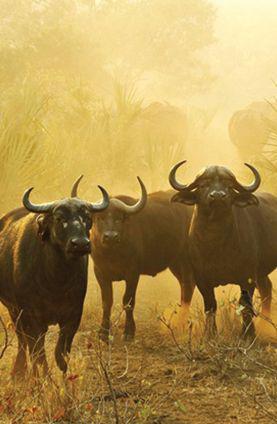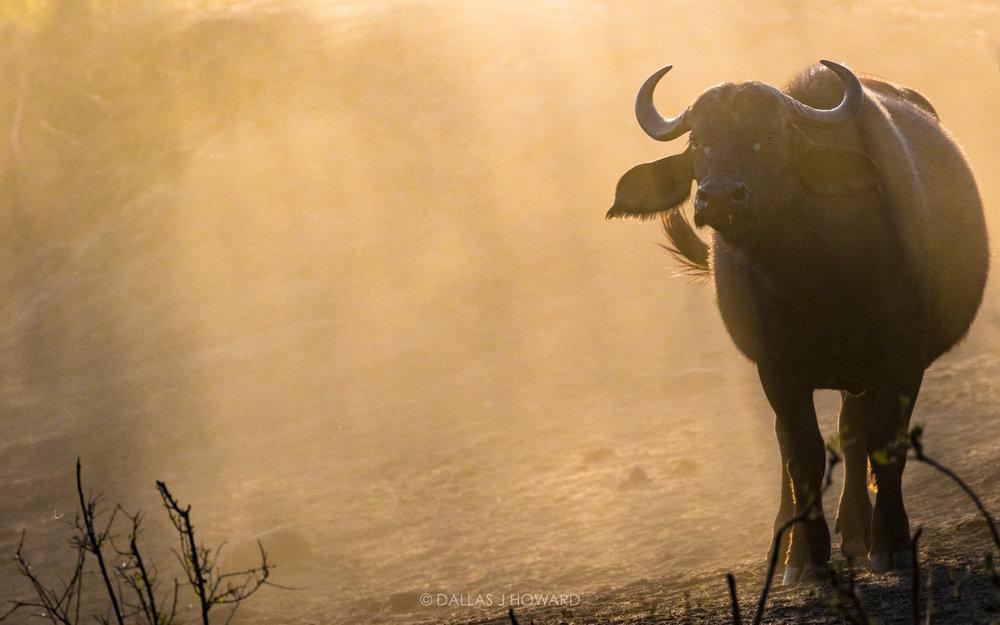The first image is the image on the left, the second image is the image on the right. Given the left and right images, does the statement "In at least one image there is only a single bull up to its chest in water." hold true? Answer yes or no. No. The first image is the image on the left, the second image is the image on the right. For the images shown, is this caption "A cow in the image on the left is walking through the water." true? Answer yes or no. No. 